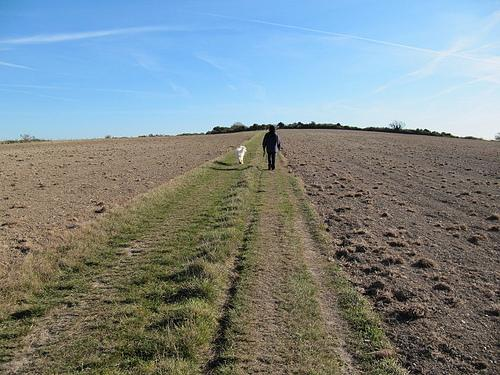What are the two beings walking in the field and describe their appearance. A man dressed in black and a white dog are walking in the field. The man's outfit is black while the dog is white in color. Describe two sections of the field on the left and right of the grassy strip. Dry field sections are present on the left and right of the grassy strip, with dirt clumps and grass throughout. What are the visible elements of the sky in the image? The sky is blue with white clouds, jet contrails, and whispy white lines. Explain the state of the field and mention the two divided sections. The field is large and barren, with left and right sides appearing dry. There's a grassy strip in the middle and some clumps of dirt and dry grass. Describe the surroundings of the person and the dog walking in the field. They are walking in a dirt field with patches of green grass along the path, and there are trees growing in the distance. Provide a brief overview of the image including the field, trees, man, and dog. The image shows a large barren field with trees and brush near the horizon line. A man is walking with a white dog along a grassy strip in the middle of the field. Explain the appearance of the trees in the image and their location. Trees are seen at the background, appearing along the horizon line, and some trees and shrubs grow in the distance. Mention the color of the dog and the outfit of the man walking. The dog is white in color, and the man walking is wearing a black outfit. What does the path in the field consist of and what grows along it? The path is made of dirt and grass, with some grasses growing alongside the path. Identify the elements in the sky and describe its color. The sky is bright blue with a few white clouds, and there are jet contrails visible above. 